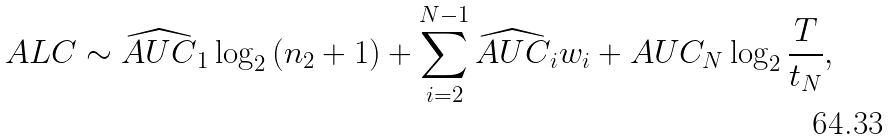<formula> <loc_0><loc_0><loc_500><loc_500>A L C \sim \widehat { A U C } _ { 1 } \log _ { 2 } { ( n _ { 2 } + 1 ) } + \sum _ { i = 2 } ^ { N - 1 } \widehat { A U C } _ { i } w _ { i } + A U C _ { N } \log _ { 2 } { \frac { T } { t _ { N } } } ,</formula> 